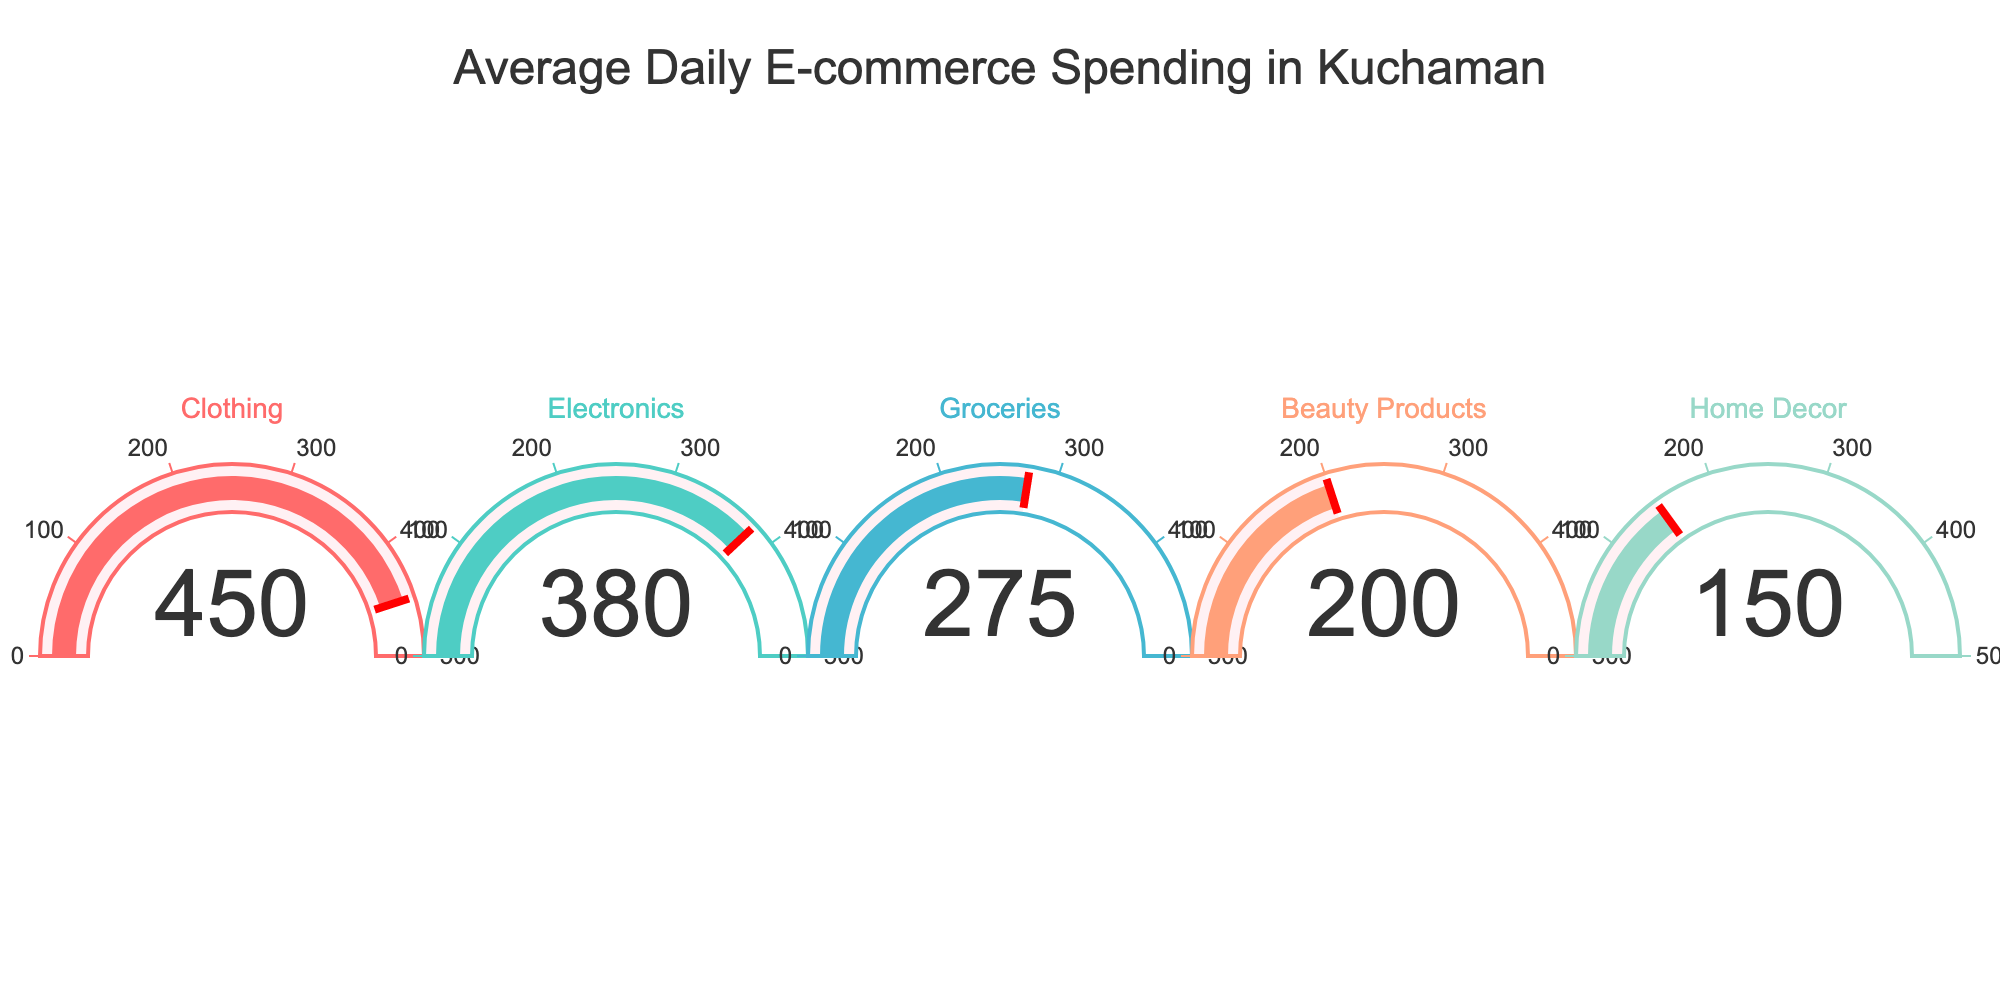Which category has the highest average daily spending? By looking at the gauge chart, the category with the needle pointing to the highest value represents the highest average daily spending. In this case, the Clothing category shows the highest value at 450 INR.
Answer: Clothing Which category has the lowest average daily spending? By identifying the gauge with the needle pointing to the smallest value, we can see that the Home Decor category has the lowest average daily spending at 150 INR.
Answer: Home Decor What is the total average daily spending for Electronics and Groceries combined? To find the combined spending, we add the individual values for Electronics (380 INR) and Groceries (275 INR). This gives us a total of 380 + 275 = 655 INR.
Answer: 655 INR How much more is spent on Clothing daily compared to Beauty Products? To find the difference, subtract the average daily spending on Beauty Products (200 INR) from the spending on Clothing (450 INR). The difference is 450 - 200 = 250 INR.
Answer: 250 INR What is the average daily spending across all categories? Add the average daily spending for all categories (450 + 380 + 275 + 200 + 150) and divide by the number of categories (5). The result is (450 + 380 + 275 + 200 + 150) / 5 = 1455 / 5 = 291 INR.
Answer: 291 INR Which category has a spending value closest to the median average daily spending? First, list the values in ascending order: 150, 200, 275, 380, 450. The median value is the third value in this ordered list, which is 275 INR. Therefore, the Groceries category has a spending value closest to the median.
Answer: Groceries Are any categories’ average daily spending values the same? By inspecting each gauge, we can see that all values displayed are unique: 450, 380, 275, 200, and 150. Therefore, no categories share the same average daily spending value.
Answer: No By how much does the average daily spending on Electronics exceed that of Home Decor? Subtract the average daily spending on Home Decor (150 INR) from the spending on Electronics (380 INR). This gives a difference of 380 - 150 = 230 INR.
Answer: 230 INR Which category falls in the middle range in terms of average daily spending in the gauge chart? By ordering the categories based on their spending values: Home Decor (150), Beauty Products (200), Groceries (275), Electronics (380), Clothing (450), the middle category is Groceries with 275 INR.
Answer: Groceries If the spending on Beauty Products increases by 50 INR, which category will have the second-highest average daily spending? If Beauty Products increases from 200 INR to 250 INR, we re-evaluate the rankings: Clothing (450), Electronics (380), Beauty Products (250), Groceries (275), Home Decor (150). Thus, Electronics will still have the second-highest spending with 380 INR.
Answer: Electronics 